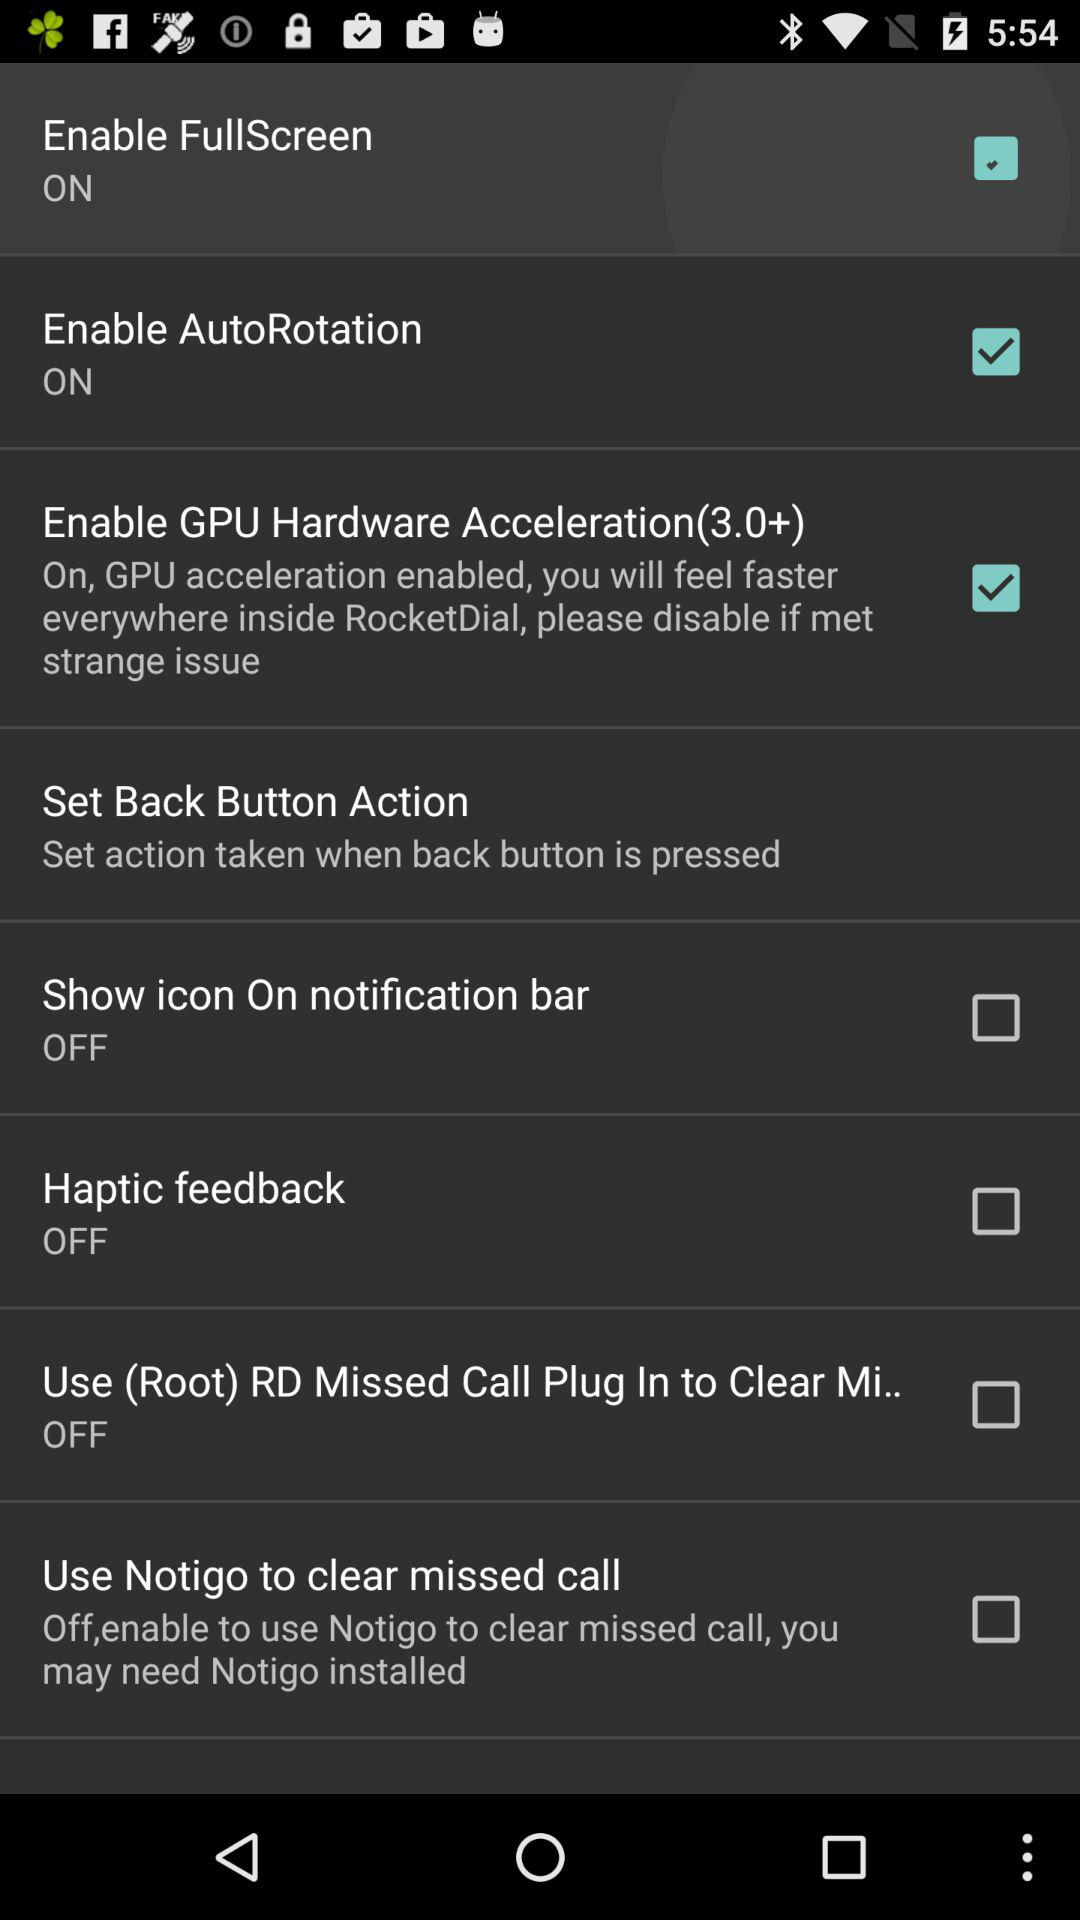How many checkboxes are turned on?
Answer the question using a single word or phrase. 3 